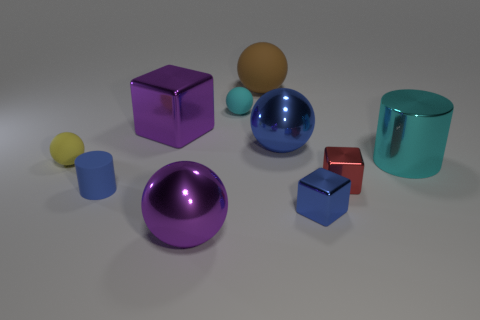Are there any big shiny objects that have the same color as the big shiny block?
Provide a succinct answer. Yes. Are there more large things in front of the brown rubber thing than tiny red shiny things?
Give a very brief answer. Yes. There is a small cyan thing; does it have the same shape as the big shiny thing that is in front of the yellow sphere?
Provide a succinct answer. Yes. Is there a tiny yellow ball?
Provide a short and direct response. Yes. How many big things are either green shiny cylinders or cyan rubber balls?
Your answer should be compact. 0. Is the number of large metallic cylinders that are left of the blue metallic cube greater than the number of purple metallic objects in front of the big brown object?
Ensure brevity in your answer.  No. Is the material of the big blue sphere the same as the cyan thing that is right of the brown rubber sphere?
Give a very brief answer. Yes. What is the color of the small cylinder?
Offer a terse response. Blue. What is the shape of the cyan object left of the brown ball?
Make the answer very short. Sphere. What number of cyan things are matte objects or large cubes?
Provide a short and direct response. 1. 